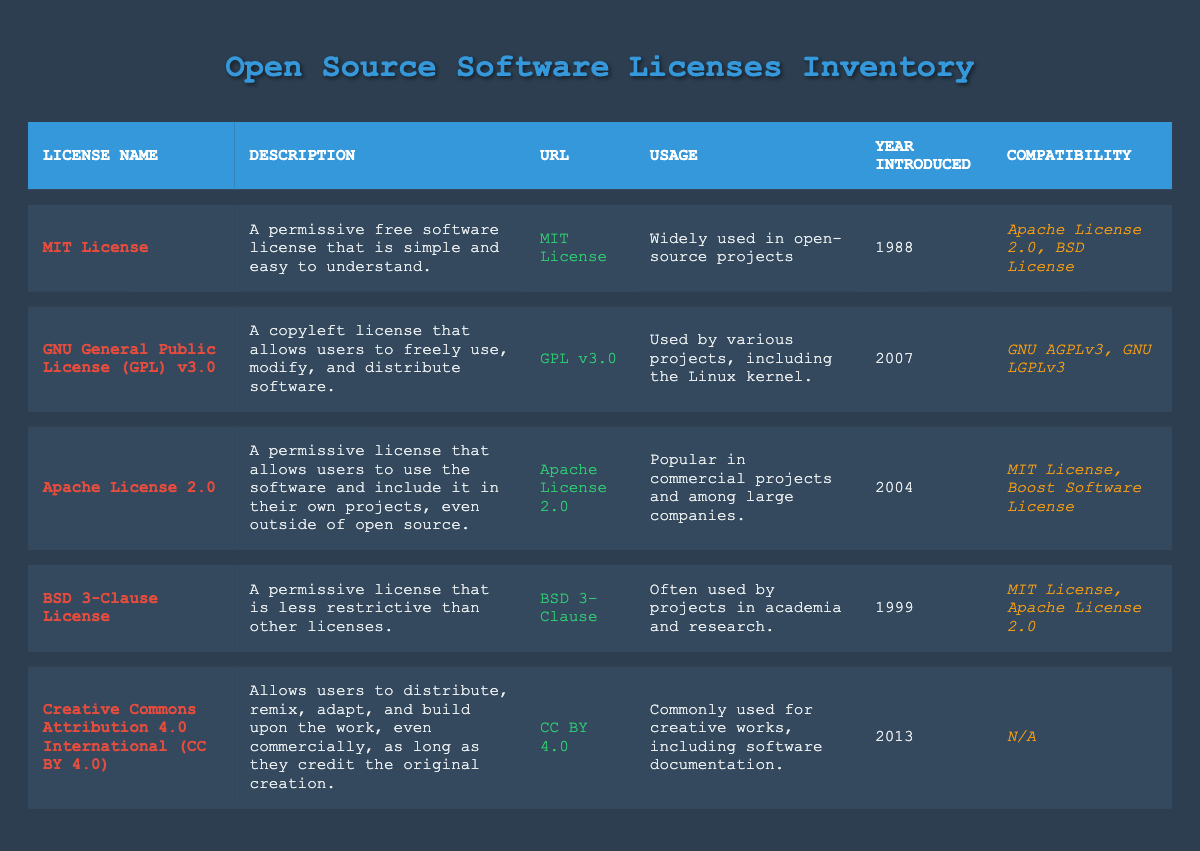What is the URL for the MIT License? The table states that the URL for the MIT License is https://opensource.org/licenses/MIT.
Answer: https://opensource.org/licenses/MIT Which license was introduced in 2004? By checking the 'Year Introduced' column in the table, we see that the license introduced in 2004 is the Apache License 2.0.
Answer: Apache License 2.0 Is the BSD 3-Clause License compatible with the MIT License? The table indicates that the BSD 3-Clause License is compatible with the MIT License, as it is listed in the 'Compatibility' column.
Answer: Yes How many licenses were introduced before 2000? The licenses before 2000 are the MIT License (1988) and the BSD 3-Clause License (1999), totaling 2.
Answer: 2 Which license allows commercial use while requiring credit to the original creation? The table shows that the Creative Commons Attribution 4.0 International (CC BY 4.0) allows users to distribute, remix, adapt, and build upon the work commercially as long as they credit the original creation.
Answer: Creative Commons Attribution 4.0 International (CC BY 4.0) What is the most recent license introduced? Looking at the 'Year Introduced' column, the most recent license is the Creative Commons Attribution 4.0 International (CC BY 4.0), introduced in 2013.
Answer: Creative Commons Attribution 4.0 International (CC BY 4.0) Do all licenses listed in the table allow modifications? Examining the licenses, all except for the Creative Commons Attribution 4.0 International (CC BY 4.0) allow modifications, so the answer is false.
Answer: No Which licenses are compatible with the GNU General Public License (GPL) v3.0? The table states that the licenses compatible with the GNU General Public License (GPL) v3.0 are GNU AGPLv3 and GNU LGPLv3, both listed in the 'Compatibility' column.
Answer: GNU AGPLv3, GNU LGPLv3 How many total licenses are listed in the inventory? Counting the entries in the inventory table, there are 5 licenses listed.
Answer: 5 